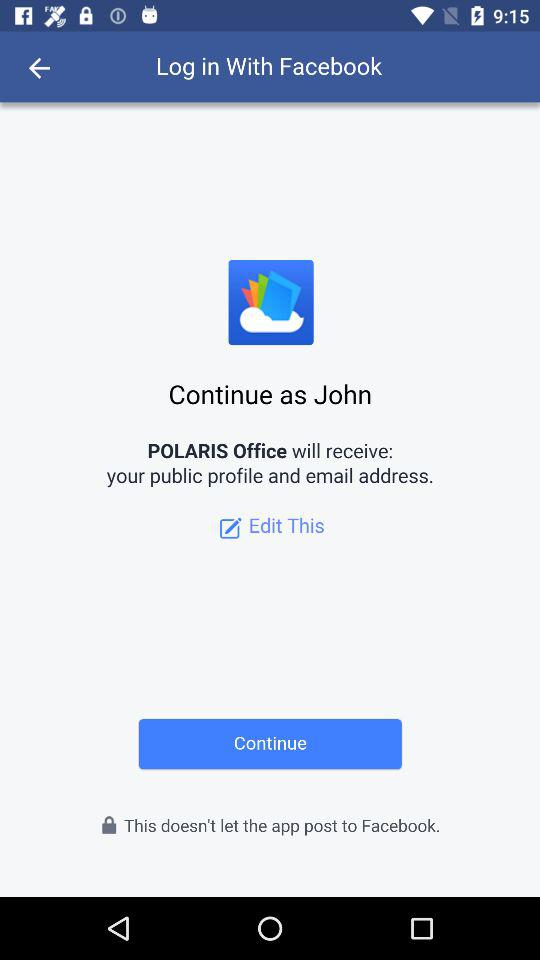What is the name of the user? The name of the user is John. 